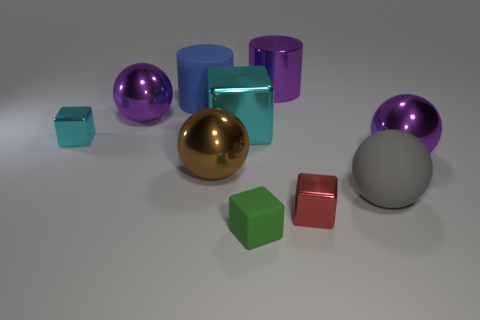Subtract all green spheres. How many cyan cubes are left? 2 Subtract all cyan spheres. Subtract all purple cylinders. How many spheres are left? 4 Subtract all cubes. How many objects are left? 6 Add 7 metallic balls. How many metallic balls exist? 10 Subtract 0 red spheres. How many objects are left? 10 Subtract all large cyan things. Subtract all big purple cylinders. How many objects are left? 8 Add 1 green cubes. How many green cubes are left? 2 